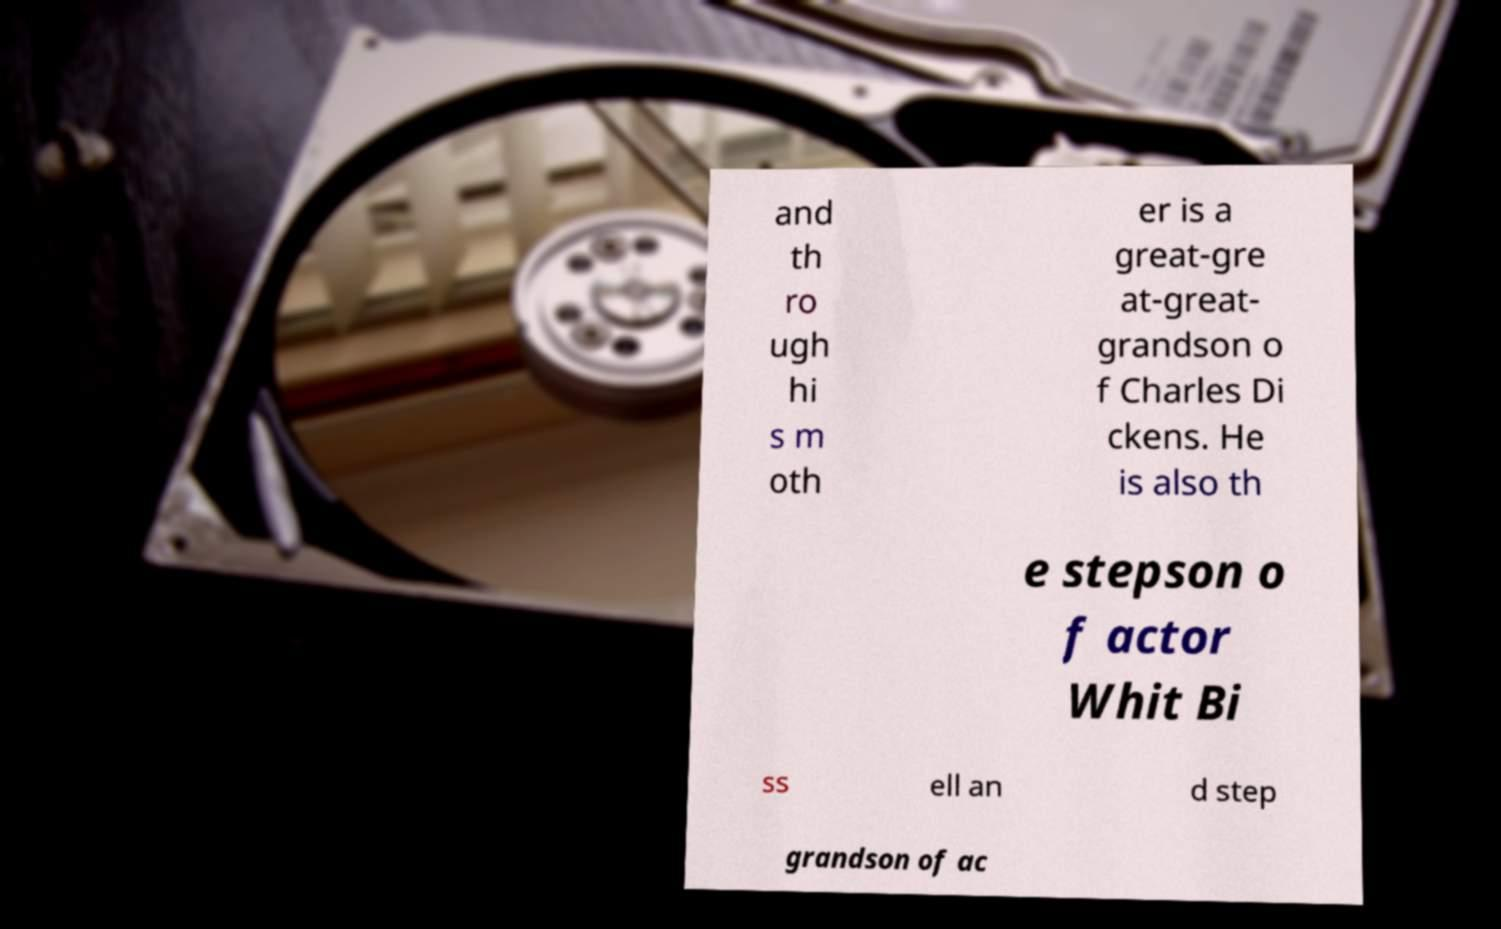I need the written content from this picture converted into text. Can you do that? and th ro ugh hi s m oth er is a great-gre at-great- grandson o f Charles Di ckens. He is also th e stepson o f actor Whit Bi ss ell an d step grandson of ac 